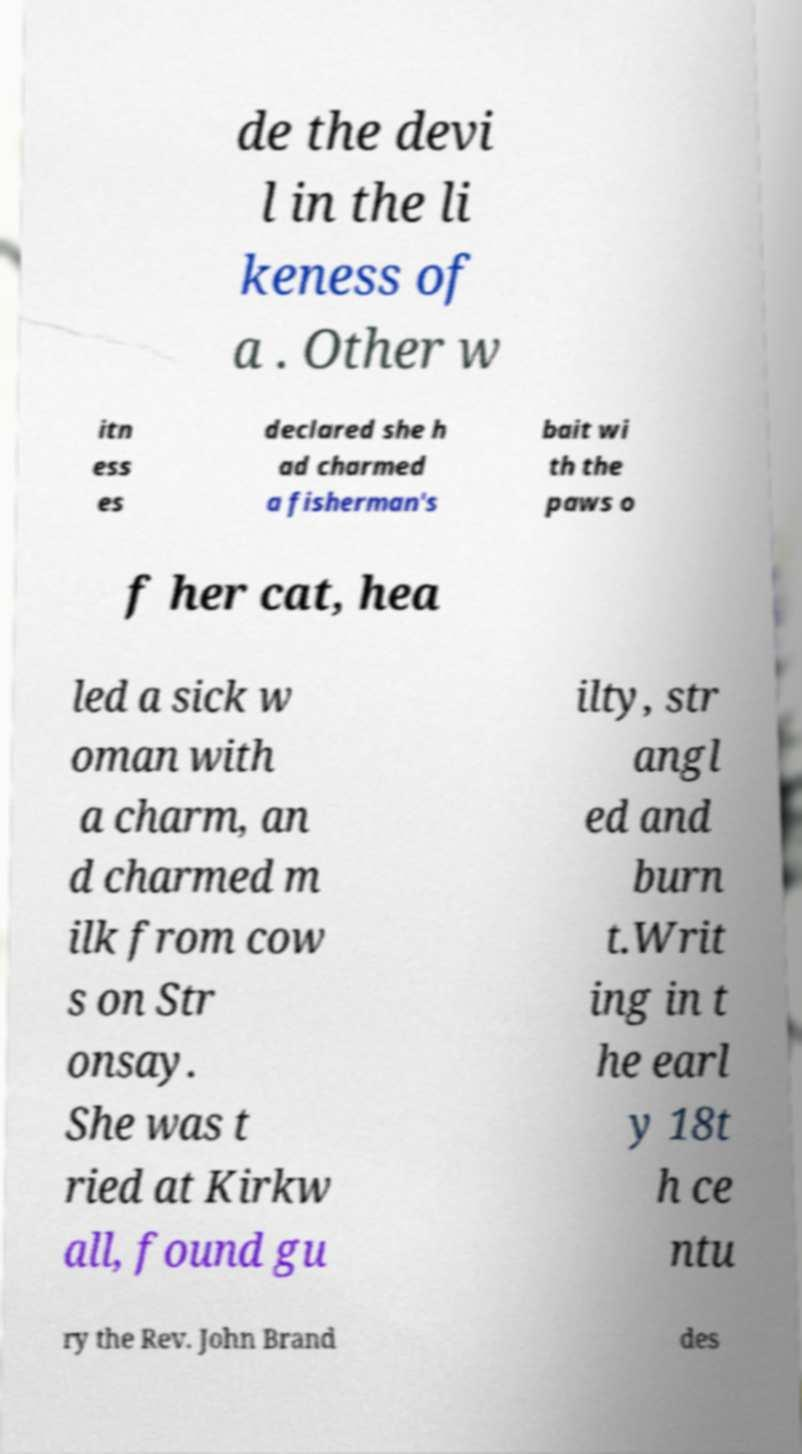What messages or text are displayed in this image? I need them in a readable, typed format. de the devi l in the li keness of a . Other w itn ess es declared she h ad charmed a fisherman's bait wi th the paws o f her cat, hea led a sick w oman with a charm, an d charmed m ilk from cow s on Str onsay. She was t ried at Kirkw all, found gu ilty, str angl ed and burn t.Writ ing in t he earl y 18t h ce ntu ry the Rev. John Brand des 